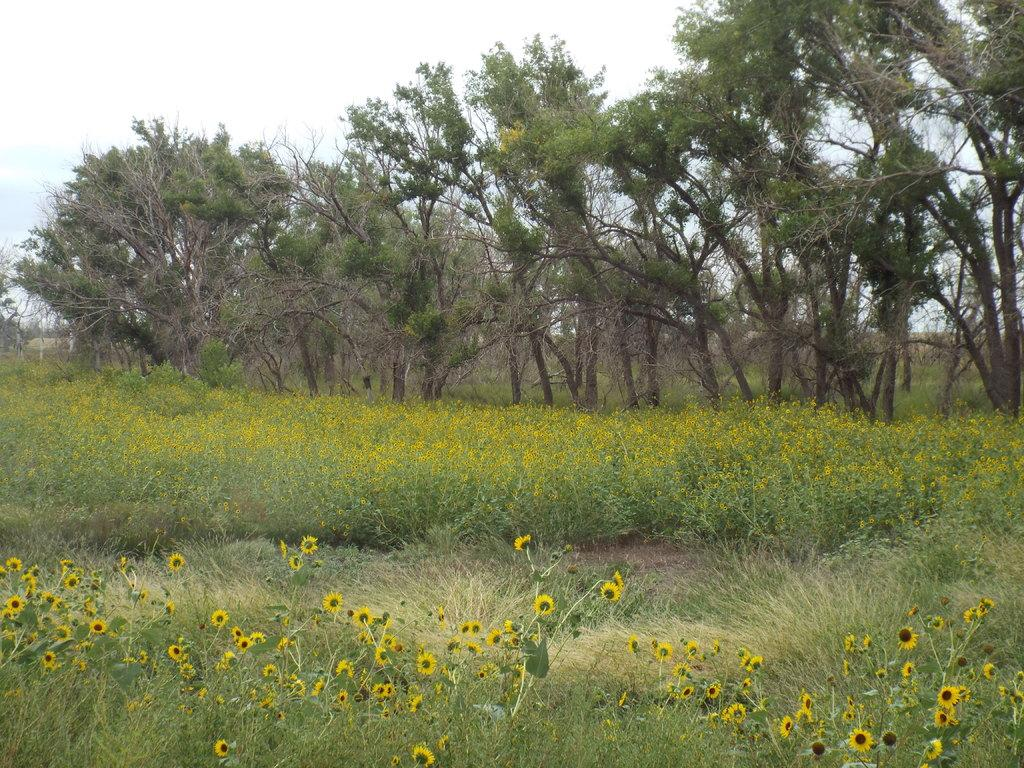What is visible on the ground in the image? The ground is visible in the image. What type of vegetation can be seen in the image? There are plants, grass, flowers, and trees in the image. What part of the natural environment is visible in the image? The sky is visible in the image. What type of machine can be seen in the image? There is no machine present in the image. Who is the minister in the image? There is no minister present in the image. 